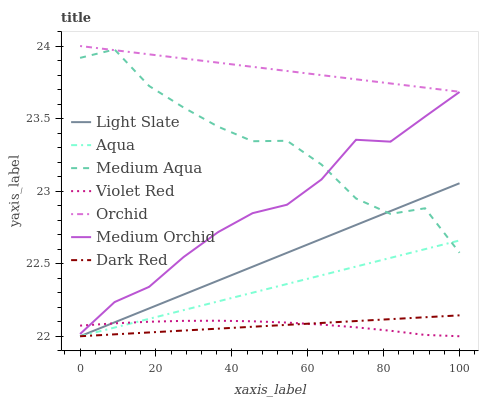Does Dark Red have the minimum area under the curve?
Answer yes or no. Yes. Does Orchid have the maximum area under the curve?
Answer yes or no. Yes. Does Light Slate have the minimum area under the curve?
Answer yes or no. No. Does Light Slate have the maximum area under the curve?
Answer yes or no. No. Is Aqua the smoothest?
Answer yes or no. Yes. Is Medium Aqua the roughest?
Answer yes or no. Yes. Is Light Slate the smoothest?
Answer yes or no. No. Is Light Slate the roughest?
Answer yes or no. No. Does Violet Red have the lowest value?
Answer yes or no. Yes. Does Medium Orchid have the lowest value?
Answer yes or no. No. Does Orchid have the highest value?
Answer yes or no. Yes. Does Light Slate have the highest value?
Answer yes or no. No. Is Aqua less than Medium Orchid?
Answer yes or no. Yes. Is Medium Orchid greater than Light Slate?
Answer yes or no. Yes. Does Dark Red intersect Aqua?
Answer yes or no. Yes. Is Dark Red less than Aqua?
Answer yes or no. No. Is Dark Red greater than Aqua?
Answer yes or no. No. Does Aqua intersect Medium Orchid?
Answer yes or no. No. 